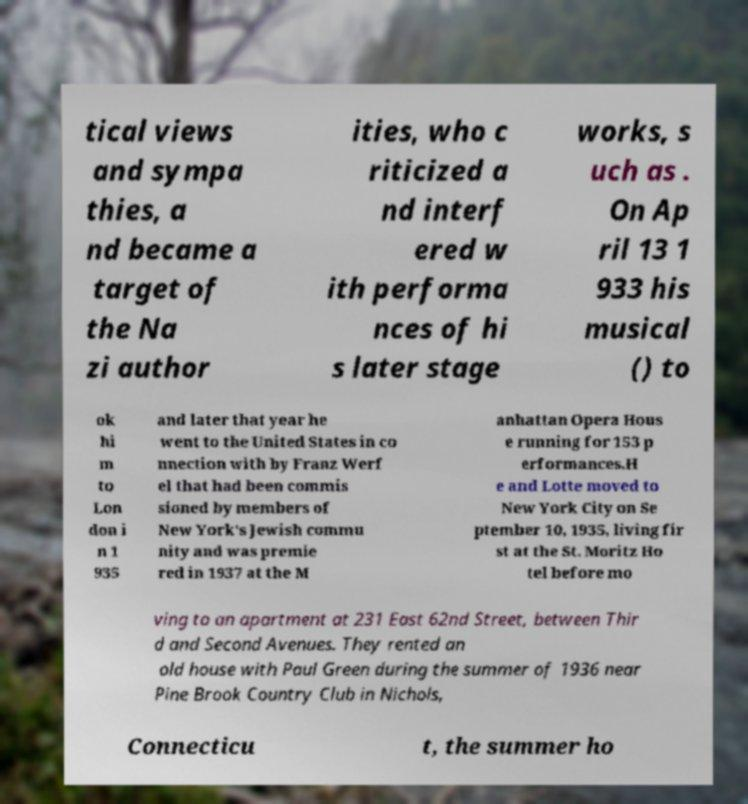Could you assist in decoding the text presented in this image and type it out clearly? tical views and sympa thies, a nd became a target of the Na zi author ities, who c riticized a nd interf ered w ith performa nces of hi s later stage works, s uch as . On Ap ril 13 1 933 his musical () to ok hi m to Lon don i n 1 935 and later that year he went to the United States in co nnection with by Franz Werf el that had been commis sioned by members of New York's Jewish commu nity and was premie red in 1937 at the M anhattan Opera Hous e running for 153 p erformances.H e and Lotte moved to New York City on Se ptember 10, 1935, living fir st at the St. Moritz Ho tel before mo ving to an apartment at 231 East 62nd Street, between Thir d and Second Avenues. They rented an old house with Paul Green during the summer of 1936 near Pine Brook Country Club in Nichols, Connecticu t, the summer ho 